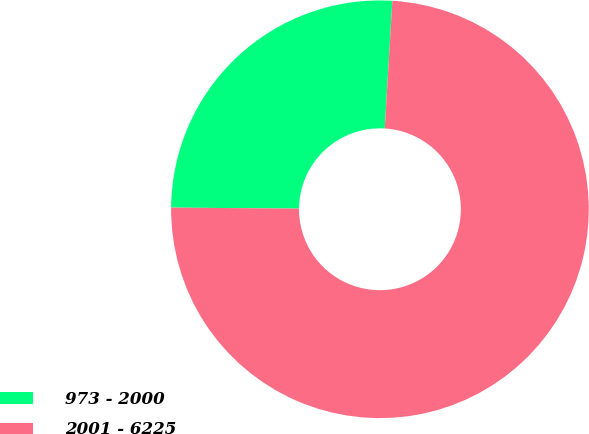Convert chart. <chart><loc_0><loc_0><loc_500><loc_500><pie_chart><fcel>973 - 2000<fcel>2001 - 6225<nl><fcel>25.82%<fcel>74.18%<nl></chart> 